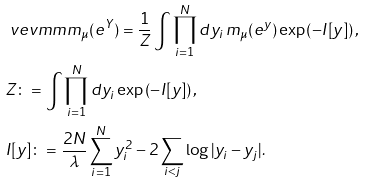Convert formula to latex. <formula><loc_0><loc_0><loc_500><loc_500>& \ v e v m m { m _ { \mu } ( e ^ { Y } ) } = \frac { 1 } { Z } \int \prod _ { i = 1 } ^ { N } d y _ { i } \, m _ { \mu } ( e ^ { y } ) \exp \left ( - I [ y ] \right ) , \\ & Z \colon = \int \prod _ { i = 1 } ^ { N } d y _ { i } \exp \left ( - I [ y ] \right ) , \\ & I [ y ] \colon = \frac { 2 N } { \lambda } \sum _ { i = 1 } ^ { N } y _ { i } ^ { 2 } - 2 \sum _ { i < j } \log | y _ { i } - y _ { j } | .</formula> 